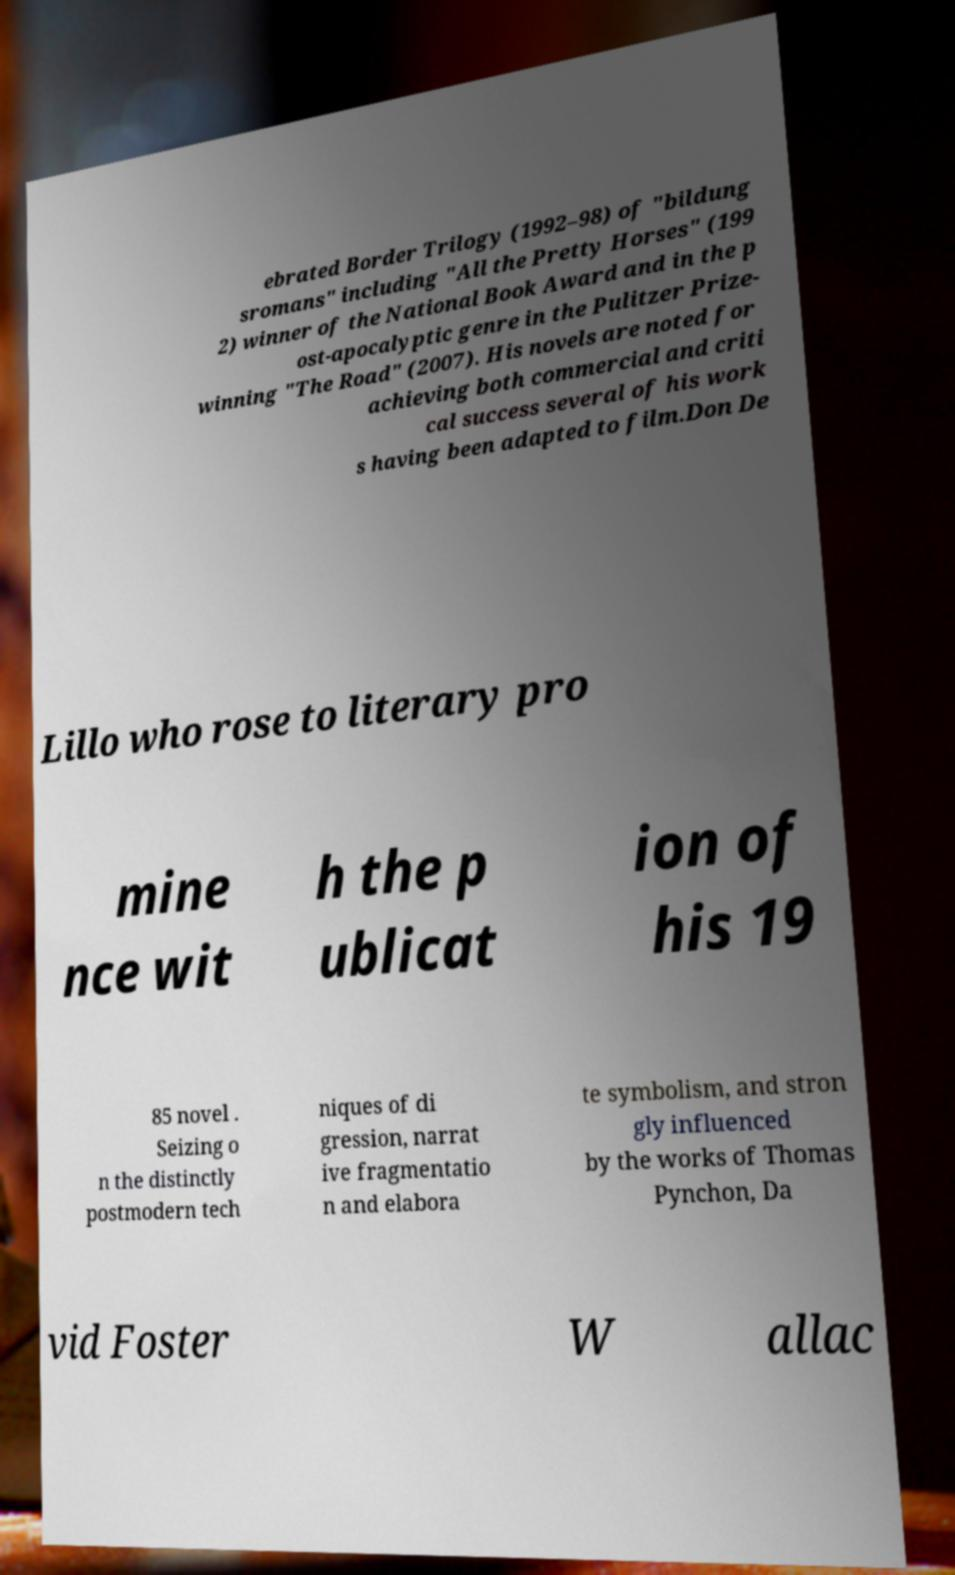Can you accurately transcribe the text from the provided image for me? ebrated Border Trilogy (1992–98) of "bildung sromans" including "All the Pretty Horses" (199 2) winner of the National Book Award and in the p ost-apocalyptic genre in the Pulitzer Prize- winning "The Road" (2007). His novels are noted for achieving both commercial and criti cal success several of his work s having been adapted to film.Don De Lillo who rose to literary pro mine nce wit h the p ublicat ion of his 19 85 novel . Seizing o n the distinctly postmodern tech niques of di gression, narrat ive fragmentatio n and elabora te symbolism, and stron gly influenced by the works of Thomas Pynchon, Da vid Foster W allac 